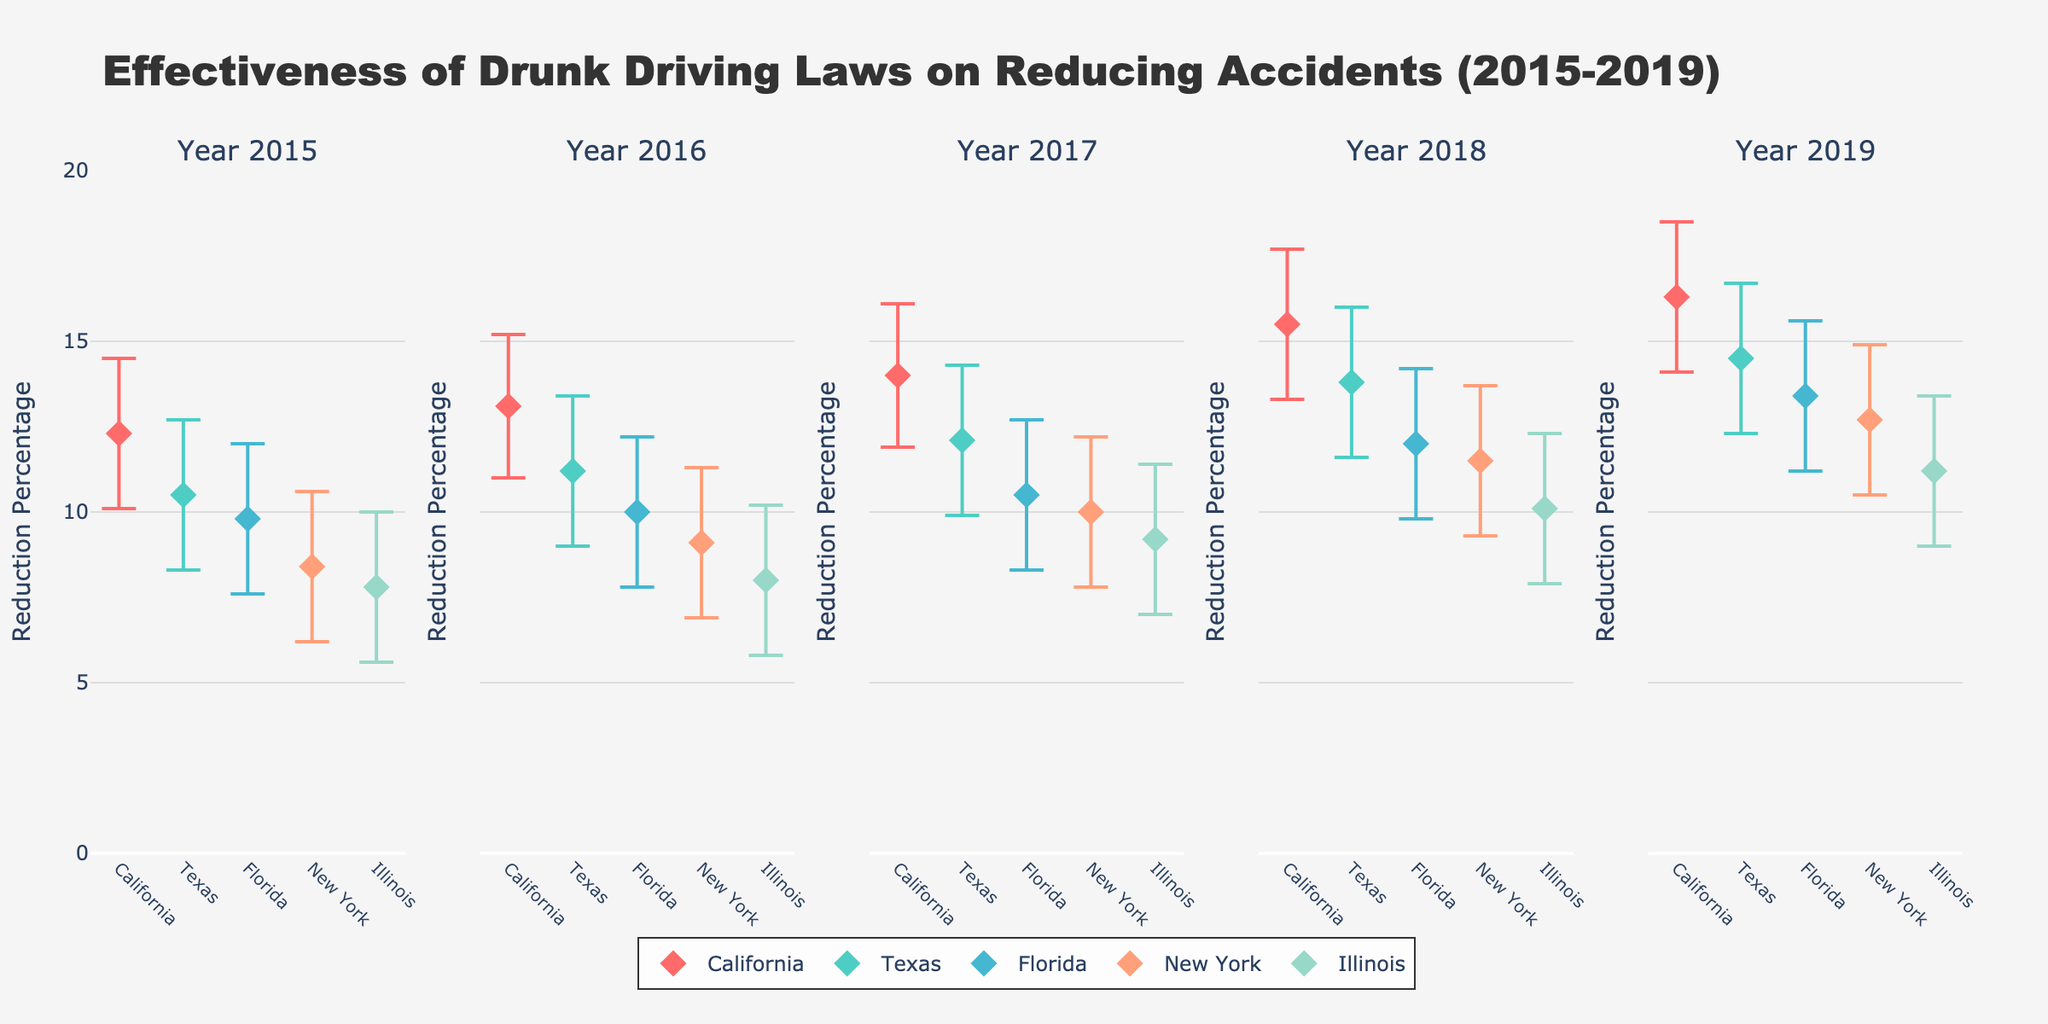What is the highest reduction percentage reported in the figure? The highest reduction percentage is observed for California in 2019. This can be seen in the subplot for 2019, where California has a reduction percentage of 16.3%.
Answer: 16.3% Which state had the lowest reduction percentage in 2015? By examining the 2015 subplot, we can observe that Illinois had the lowest reduction percentage among the states, with a value of 7.8%.
Answer: Illinois How does the reduction percentage for New York change from 2015 to 2019? In the 2015 subplot, New York has a reduction percentage of 8.4%. By 2019, this percentage increases to 12.7%. The change is 12.7% - 8.4% = 4.3%.
Answer: 4.3% Which state shows the most consistent improvement over the years? By comparing the subplots from 2015 to 2019, California shows a consistent improvement, with increasing reduction percentages each year: 12.3% in 2015, 13.1% in 2016, 14.0% in 2017, 15.5% in 2018, and 16.3% in 2019.
Answer: California In which year did Texas see the largest improvement in reduction percentage compared to the previous year? Texas had the largest improvement in reduction percentage between 2017 and 2018. It increased by 13.8% - 12.1% = 1.7%.
Answer: 2018 What is the average reduction percentage for Florida across all years? Adding Florida's reduction percentages from each year: 9.8% (2015), 10.0% (2016), 10.5% (2017), 12.0% (2018), and 13.4% (2019) = 55.7%. Dividing this sum by 5 years gives an average of 55.7% / 5 = 11.14%.
Answer: 11.14% Which state had the smallest confidence interval in 2019? In the 2019 subplot, Illinois has the smallest confidence interval. The values for the lower and upper bounds are 9.0 and 13.4, respectively, resulting in a confidence interval of 13.4 - 9.0 = 4.4%.
Answer: Illinois 